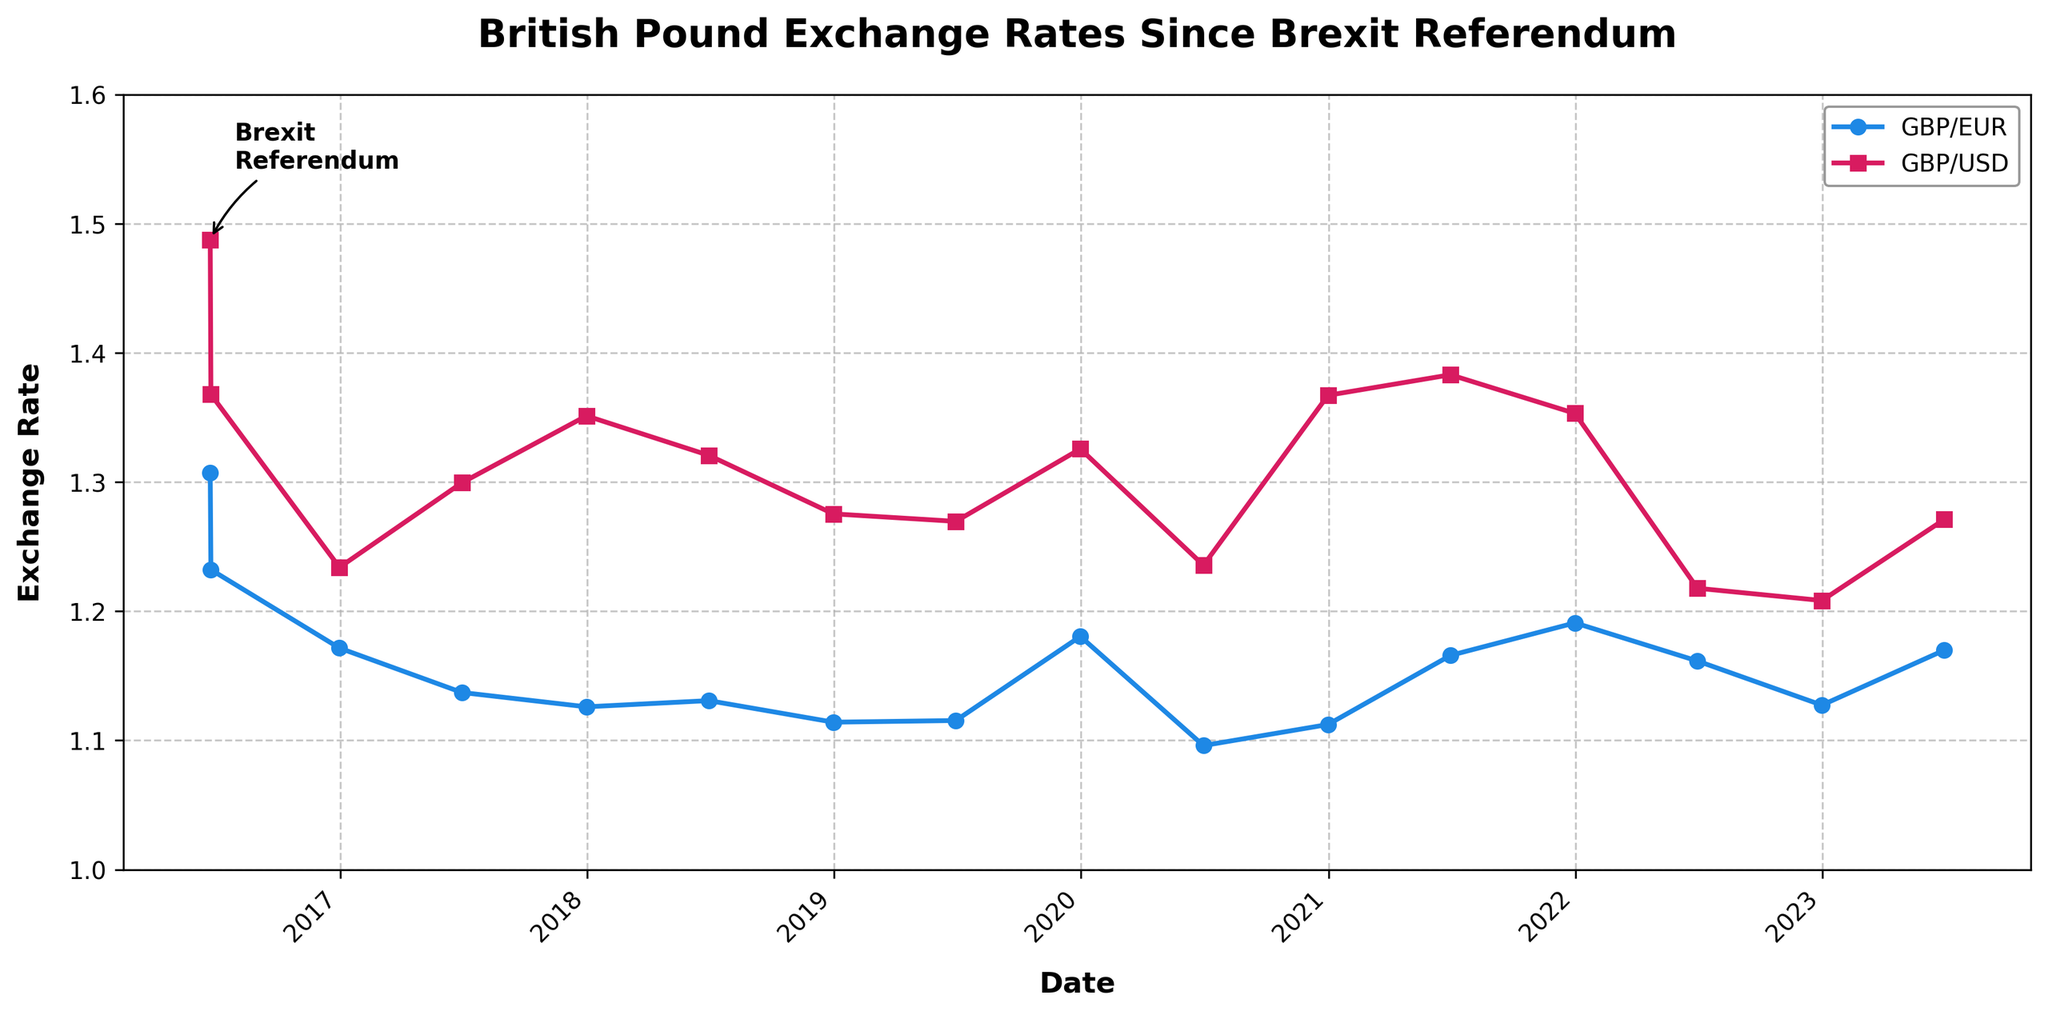What's the trend in GBP/USD exchange rate from June 2016 to June 2017? The GBP/USD exchange rate starts at 1.4877 in June 2016 and drops to about 1.2995 by June 2017. This indicates a downward trend in the GBP/USD value over the course of one year.
Answer: Downward When did the GBP/EUR exchange rate reach its lowest point, and what was the value? Observing the GBP/EUR values on the plot, the exchange rate reached its lowest point in June 2020, with a value of approximately 1.0960.
Answer: June 2020, 1.0960 How did the GBP/EUR exchange rate compare between December 2019 and December 2020? The GBP/EUR rate in December 2019 was about 1.1805, while in December 2020 it was approximately 1.1123. This shows a decrease in the GBP/EUR rate over the year.
Answer: Decreased Which exchange rate is generally higher throughout the period, GBP/EUR or GBP/USD? Visual inspection of the graph shows that the GBP/USD exchange rate is consistently higher than the GBP/EUR exchange rate throughout the entire period from June 2016 to June 2023.
Answer: GBP/USD What noticeable change can be seen in the GBP/EUR rate immediately after the Brexit referendum in June 2016? Right after the Brexit referendum in June 2016, the GBP/EUR rate drops significantly from around 1.3072 to approximately 1.2322.
Answer: Significant drop Has the GBP/EUR or GBP/USD exchange rate shown a larger overall decrease from June 2016 to December 2022? From June 2016 to December 2022, the GBP/EUR exchange rate decreased from 1.3072 to 1.1273, a change of 0.1799. The GBP/USD rate decreased from 1.4877 to 1.2083, a change of 0.2794. This indicates the GBP/USD showed a larger overall decrease.
Answer: GBP/USD What is the difference in GBP/USD exchange rate between December 2020 and December 2021? The GBP/USD rate in December 2020 was about 1.3672, and in December 2021 it was approximately 1.3532. The difference between these values is 1.3672 - 1.3532 = 0.0140.
Answer: 0.0140 Around what time did the GBP/USD rate recover to the same value it had immediately after the Brexit referendum? The GBP/USD rate immediately after the Brexit referendum in June 2016 was about 1.3679. It recovered to approximately the same level by December 2020, when it was around 1.3672.
Answer: December 2020 Which exchange rate experienced more volatility: GBP/EUR or GBP/USD? By comparing the fluctuations in the values on the plot, the GBP/USD exchange rate shows more significant peaks and troughs compared to the GBP/EUR rate, indicating more volatility.
Answer: GBP/USD How do the slopes of the GBP/EUR and GBP/USD rates compare from June 2022 to June 2023? From June 2022 to June 2023, GBP/EUR starts at about 1.1615 and ends at around 1.1699, showing a slight increase. For GBP/USD, the rate starts at approximately 1.2178 and ends around 1.2711, showing a larger increase. Hence, the slope of GBP/USD is steeper.
Answer: GBP/USD steeper 